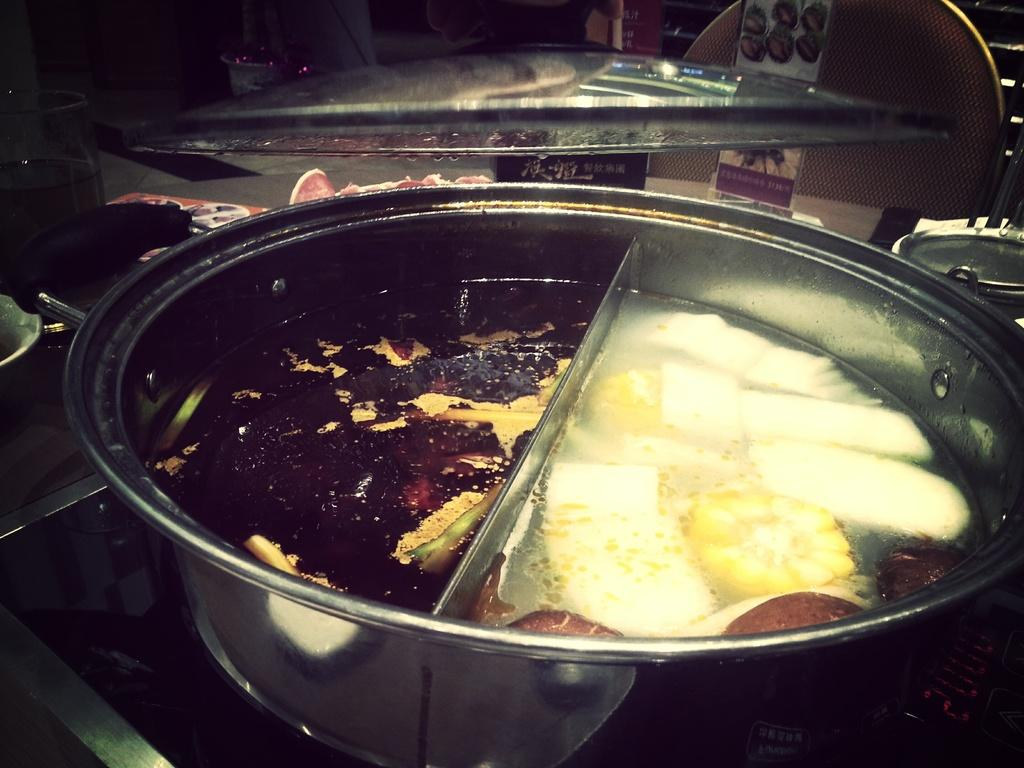What is in the bowl that is visible in the image? There is a bowl with food in the image. What other items can be seen in the image? There is a glass and a chair visible in the image. Are there any other bowls in the image? Yes, there are additional bowls in the image. What is on the wall in the image? There is a poster with images and text in the image. What type of knowledge is being traded in the image? There is no indication of knowledge or trade in the image; it primarily features a bowl with food, a glass, a chair, additional bowls, and a poster. 